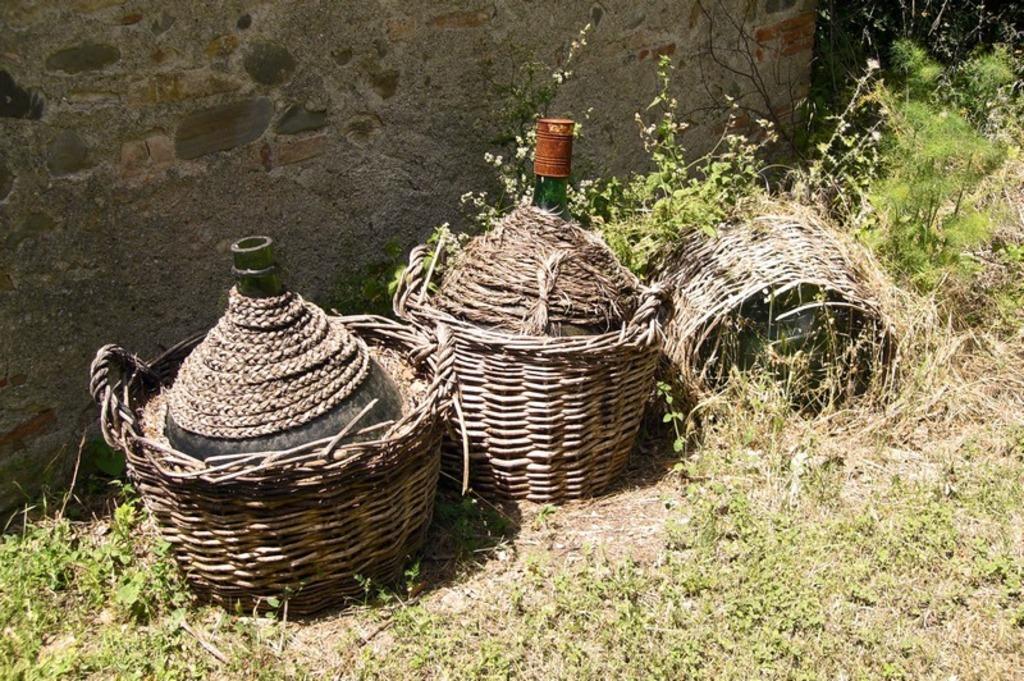How would you summarize this image in a sentence or two? In the background we can see the wall. In this picture we can see the buckets and objects. We can see the pants and the ground. 